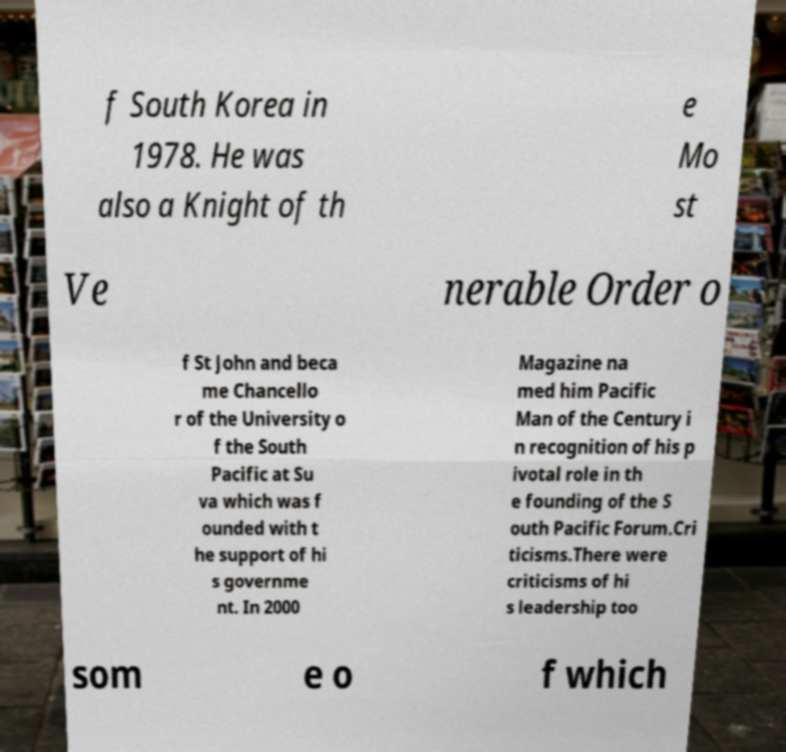Please read and relay the text visible in this image. What does it say? f South Korea in 1978. He was also a Knight of th e Mo st Ve nerable Order o f St John and beca me Chancello r of the University o f the South Pacific at Su va which was f ounded with t he support of hi s governme nt. In 2000 Magazine na med him Pacific Man of the Century i n recognition of his p ivotal role in th e founding of the S outh Pacific Forum.Cri ticisms.There were criticisms of hi s leadership too som e o f which 